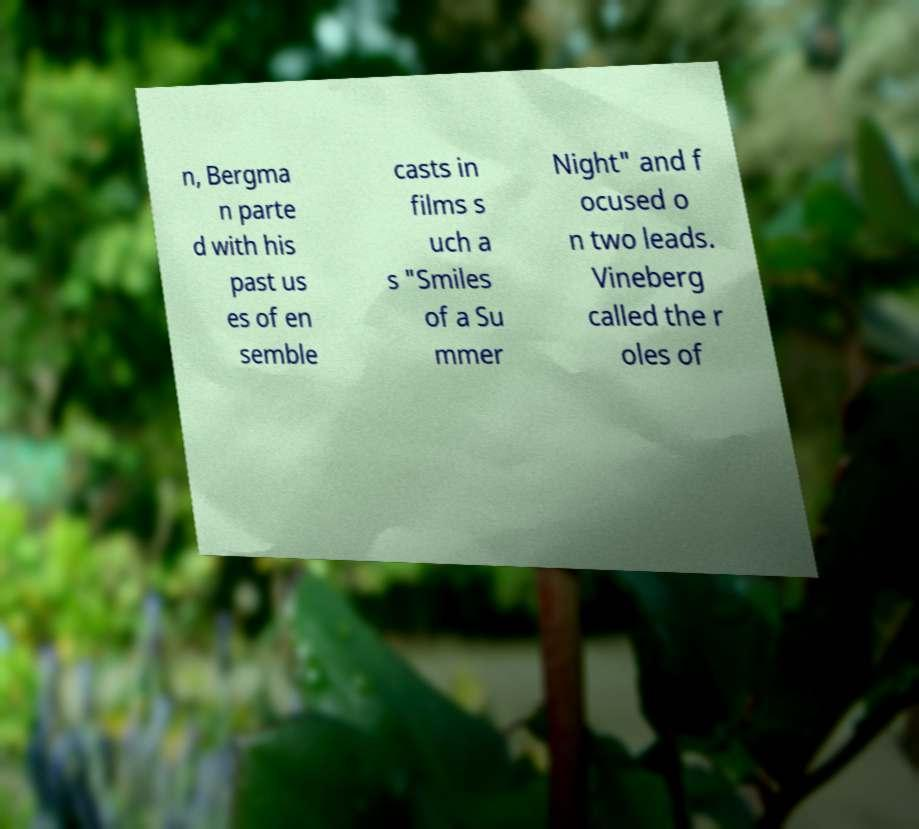Could you extract and type out the text from this image? n, Bergma n parte d with his past us es of en semble casts in films s uch a s "Smiles of a Su mmer Night" and f ocused o n two leads. Vineberg called the r oles of 